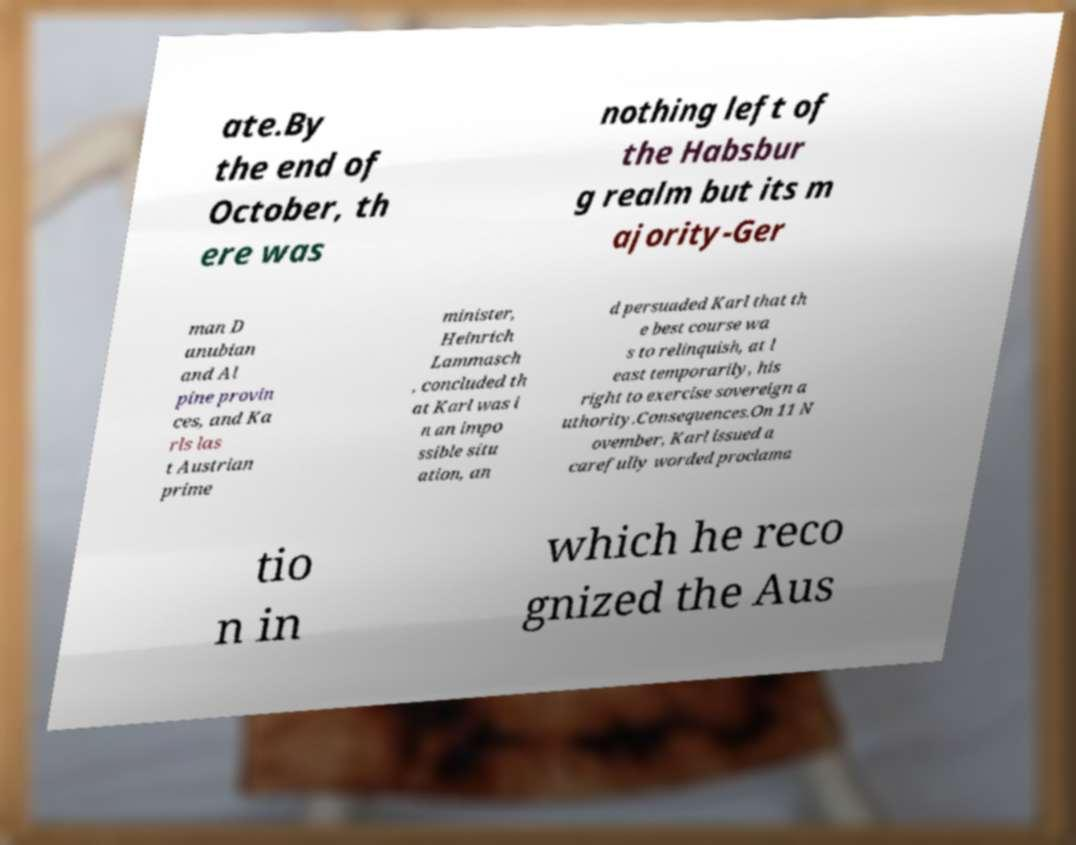I need the written content from this picture converted into text. Can you do that? ate.By the end of October, th ere was nothing left of the Habsbur g realm but its m ajority-Ger man D anubian and Al pine provin ces, and Ka rls las t Austrian prime minister, Heinrich Lammasch , concluded th at Karl was i n an impo ssible situ ation, an d persuaded Karl that th e best course wa s to relinquish, at l east temporarily, his right to exercise sovereign a uthority.Consequences.On 11 N ovember, Karl issued a carefully worded proclama tio n in which he reco gnized the Aus 